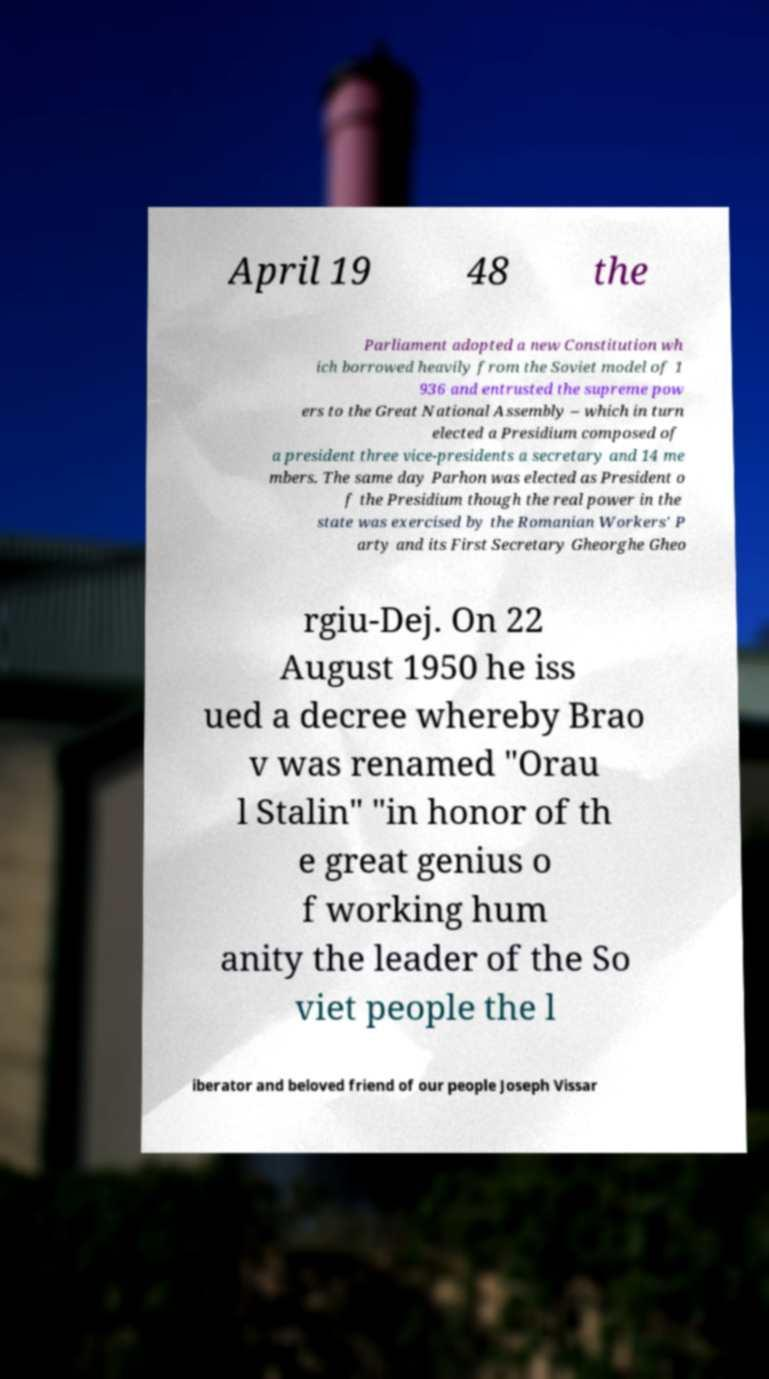Could you extract and type out the text from this image? April 19 48 the Parliament adopted a new Constitution wh ich borrowed heavily from the Soviet model of 1 936 and entrusted the supreme pow ers to the Great National Assembly – which in turn elected a Presidium composed of a president three vice-presidents a secretary and 14 me mbers. The same day Parhon was elected as President o f the Presidium though the real power in the state was exercised by the Romanian Workers' P arty and its First Secretary Gheorghe Gheo rgiu-Dej. On 22 August 1950 he iss ued a decree whereby Brao v was renamed "Orau l Stalin" "in honor of th e great genius o f working hum anity the leader of the So viet people the l iberator and beloved friend of our people Joseph Vissar 